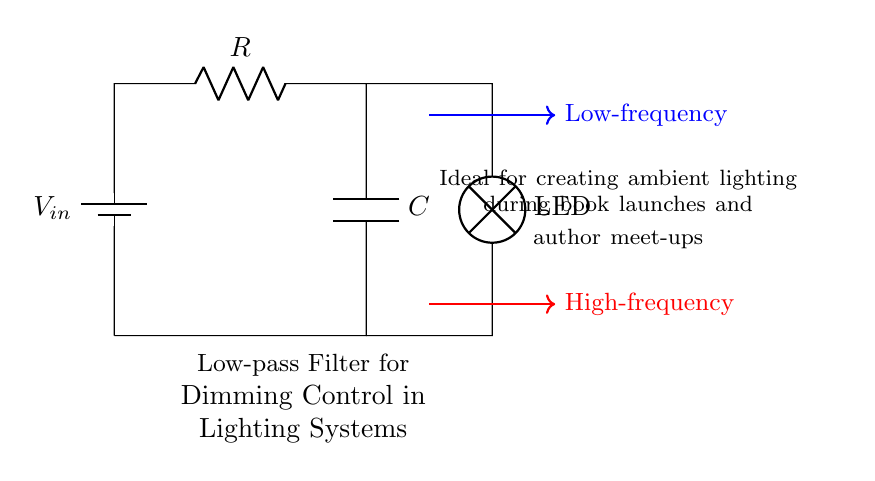What type of filter is represented in this circuit? The circuit diagram depicts a low-pass filter, indicated by the components R (resistor) and C (capacitor) arranged in series with a load device, which allows low frequencies to pass while attenuating high frequencies.
Answer: Low-pass filter What components are used in the circuit? The components visible in the circuit are a battery, a resistor, a capacitor, and an LED lamp. These components work together to form a low-pass filter system.
Answer: Battery, resistor, capacitor, LED What is the purpose of the low-pass filter in this lighting system? The low-pass filter is designed for dimming control, which creates ambient lighting suitable for events like book launches and author meet-ups. This is indicated by the description in the circuit diagram.
Answer: Dimming control What happens to high-frequency signals in this circuit? High-frequency signals are attenuated or blocked by the low-pass filter configuration of the circuit, ensuring that only low-frequency signals reach the load, in this case, the LED lamp.
Answer: Attenuated How does the voltage relate to the resistor and capacitor in this circuit? The voltage drop across the resistor and capacitor in a low-pass filter affects the output voltage seen at the load. The relationship is governed by the impedance of the resistor and capacitor at different frequencies, influencing how much voltage is passed to the LED.
Answer: Voltage drop What is the intended effect of this circuit during a book launch? The intended effect is to create ambient lighting, which enhances the atmosphere of the event by allowing gradual dimming of the LED, controlled by the characteristics of the low-pass filter.
Answer: Ambient lighting 